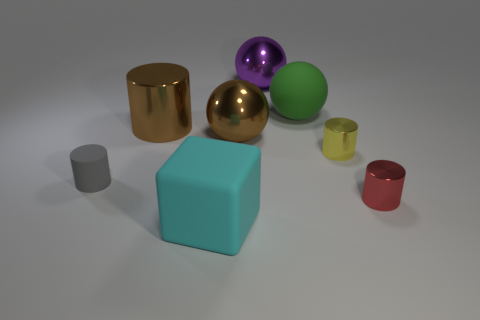Is there any other thing that has the same shape as the purple object?
Your response must be concise. Yes. What is the color of the other big thing that is the same shape as the gray matte object?
Keep it short and to the point. Brown. Do the big purple thing and the large brown metallic object that is to the right of the cube have the same shape?
Provide a succinct answer. Yes. How many objects are large spheres that are behind the big green rubber thing or things behind the brown ball?
Keep it short and to the point. 3. What is the material of the small red object?
Give a very brief answer. Metal. What number of other objects are the same size as the gray cylinder?
Provide a short and direct response. 2. There is a sphere on the left side of the large purple metal thing; what size is it?
Keep it short and to the point. Large. The thing that is behind the big matte object behind the object in front of the red thing is made of what material?
Your answer should be compact. Metal. Do the red shiny thing and the big green matte object have the same shape?
Your answer should be compact. No. What number of shiny objects are big yellow cubes or large cylinders?
Give a very brief answer. 1. 